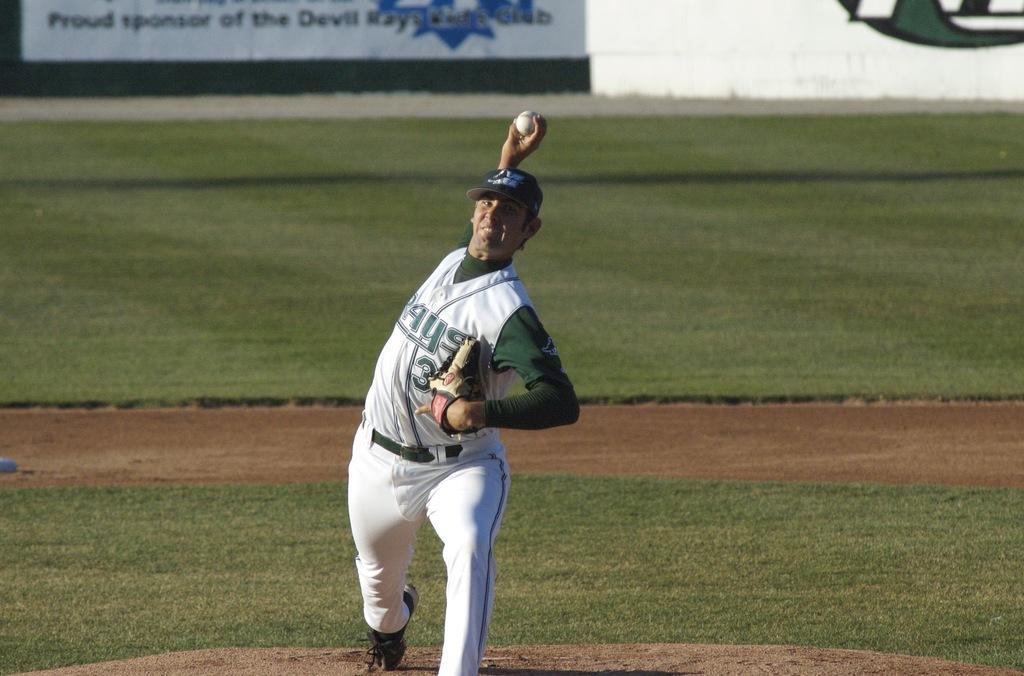In one or two sentences, can you explain what this image depicts? In this image in the front there is a person and the person is in the action of throwing a ball. In the background there is grass on the ground and there is a wall and on the wall there is some text and there are some symbols. 